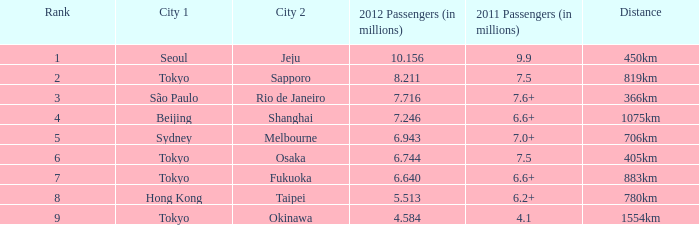On the route with 7.6 million or more passengers, which city was listed first in 2011? São Paulo. 